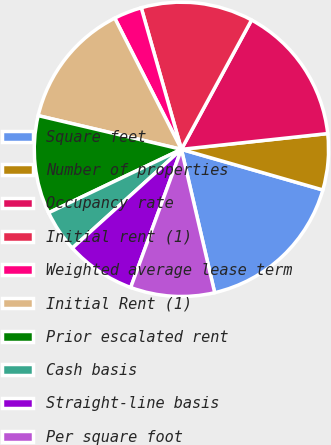Convert chart to OTSL. <chart><loc_0><loc_0><loc_500><loc_500><pie_chart><fcel>Square feet<fcel>Number of properties<fcel>Occupancy rate<fcel>Initial rent (1)<fcel>Weighted average lease term<fcel>Initial Rent (1)<fcel>Prior escalated rent<fcel>Cash basis<fcel>Straight-line basis<fcel>Per square foot<nl><fcel>16.92%<fcel>6.16%<fcel>15.38%<fcel>12.31%<fcel>3.08%<fcel>13.84%<fcel>10.77%<fcel>4.62%<fcel>7.69%<fcel>9.23%<nl></chart> 